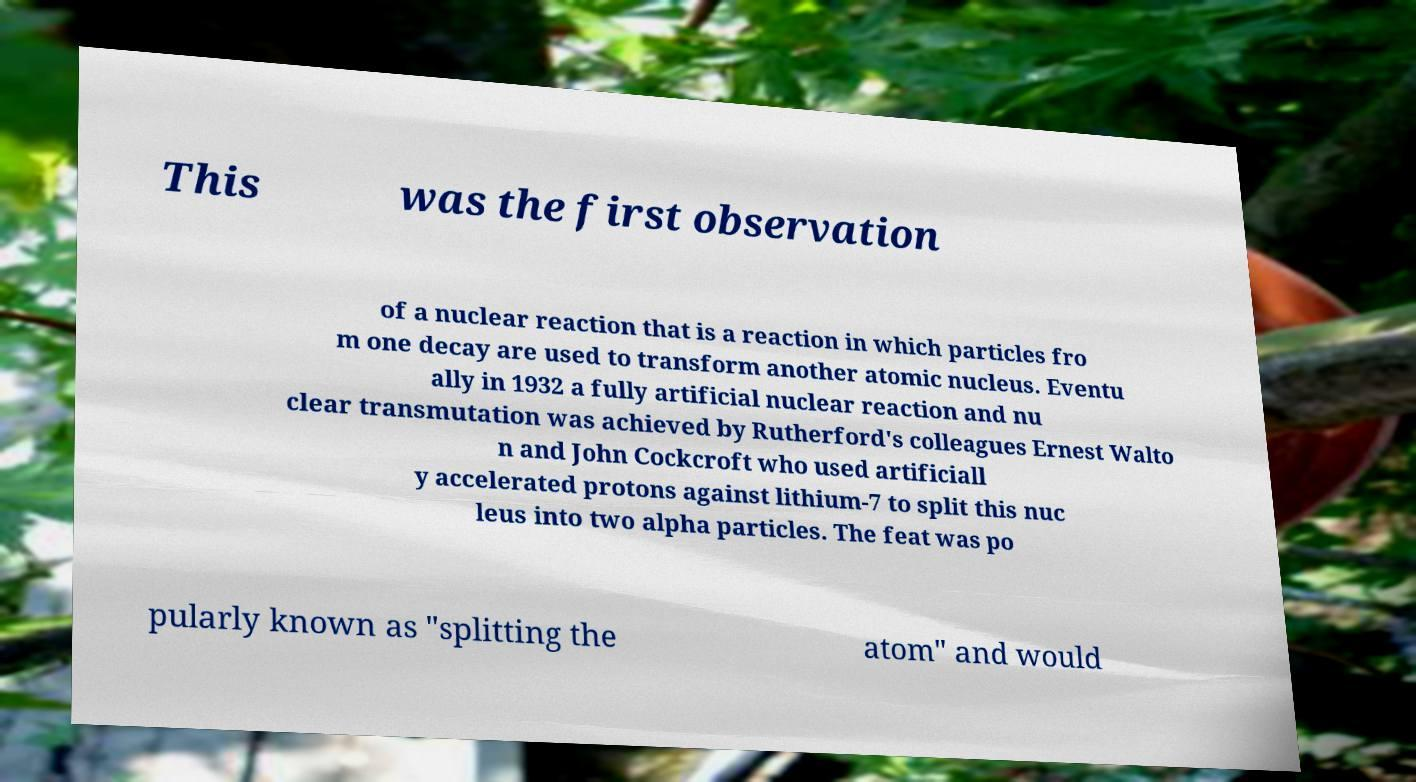Can you read and provide the text displayed in the image?This photo seems to have some interesting text. Can you extract and type it out for me? This was the first observation of a nuclear reaction that is a reaction in which particles fro m one decay are used to transform another atomic nucleus. Eventu ally in 1932 a fully artificial nuclear reaction and nu clear transmutation was achieved by Rutherford's colleagues Ernest Walto n and John Cockcroft who used artificiall y accelerated protons against lithium-7 to split this nuc leus into two alpha particles. The feat was po pularly known as "splitting the atom" and would 